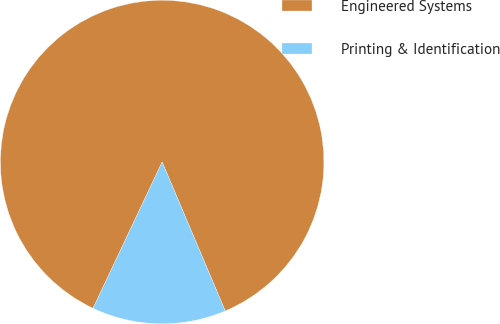Convert chart. <chart><loc_0><loc_0><loc_500><loc_500><pie_chart><fcel>Engineered Systems<fcel>Printing & Identification<nl><fcel>86.6%<fcel>13.4%<nl></chart> 